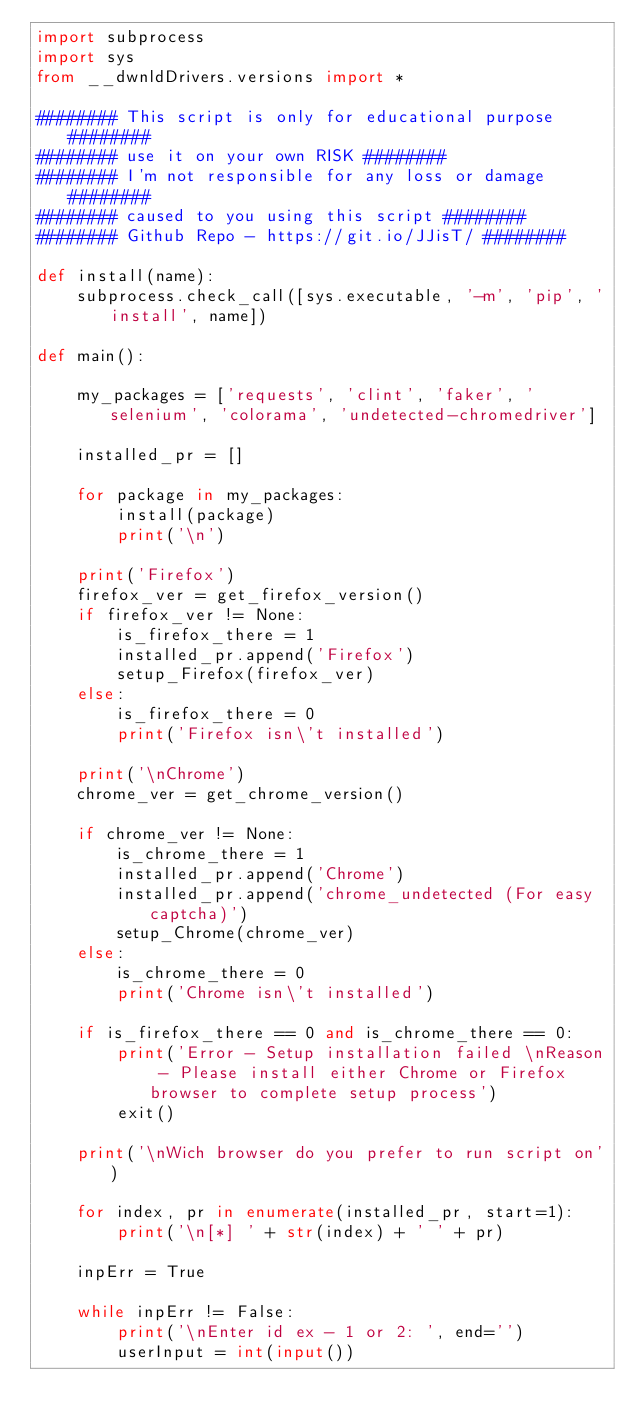<code> <loc_0><loc_0><loc_500><loc_500><_Python_>import subprocess
import sys
from __dwnldDrivers.versions import *

######## This script is only for educational purpose ########
######## use it on your own RISK ########
######## I'm not responsible for any loss or damage ########
######## caused to you using this script ########
######## Github Repo - https://git.io/JJisT/ ########

def install(name):
    subprocess.check_call([sys.executable, '-m', 'pip', 'install', name])

def main():

    my_packages = ['requests', 'clint', 'faker', 'selenium', 'colorama', 'undetected-chromedriver']

    installed_pr = [] 
    
    for package in my_packages:
        install(package)
        print('\n')

    print('Firefox')
    firefox_ver = get_firefox_version()
    if firefox_ver != None:
        is_firefox_there = 1
        installed_pr.append('Firefox')
        setup_Firefox(firefox_ver)
    else:
        is_firefox_there = 0
        print('Firefox isn\'t installed')
    
    print('\nChrome')
    chrome_ver = get_chrome_version()

    if chrome_ver != None:
        is_chrome_there = 1
        installed_pr.append('Chrome')
        installed_pr.append('chrome_undetected (For easy captcha)')
        setup_Chrome(chrome_ver)
    else:
        is_chrome_there = 0
        print('Chrome isn\'t installed')
    
    if is_firefox_there == 0 and is_chrome_there == 0:
        print('Error - Setup installation failed \nReason - Please install either Chrome or Firefox browser to complete setup process')
        exit()

    print('\nWich browser do you prefer to run script on')

    for index, pr in enumerate(installed_pr, start=1):
        print('\n[*] ' + str(index) + ' ' + pr)
    
    inpErr = True

    while inpErr != False:
        print('\nEnter id ex - 1 or 2: ', end='')
        userInput = int(input())
</code> 